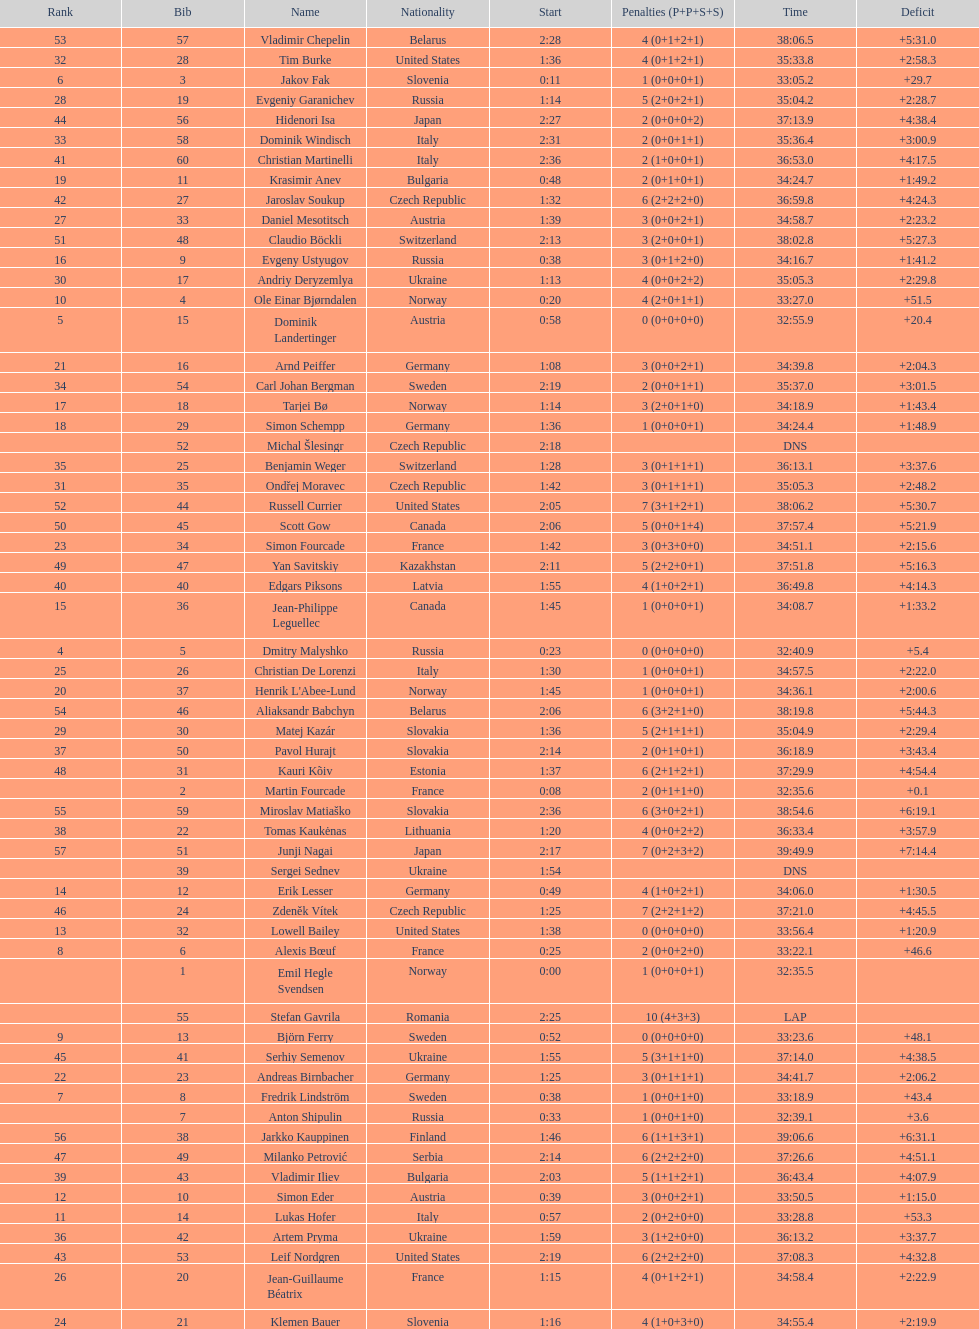What were the total number of "ties" (people who finished with the exact same time?) 2. 